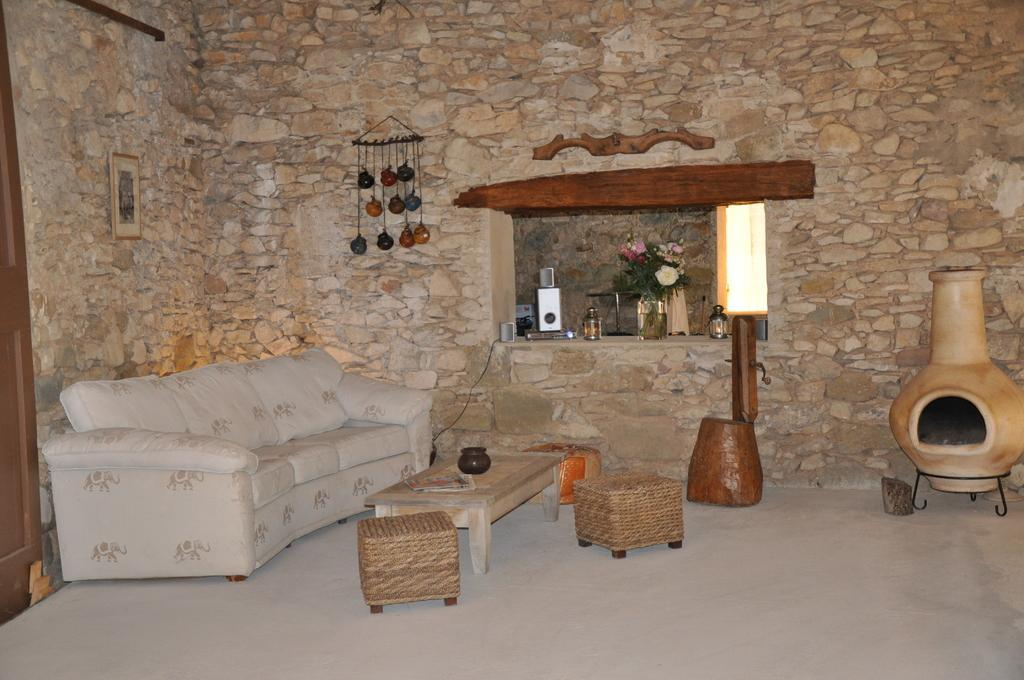What type of furniture is present in the image? There is a couch, a table, and two chairs in the image. What can be seen in the background of the image? There is a wall, a flower pot, and another table in the background of the image. Can you see a squirrel climbing the wall in the image? There is no squirrel present in the image. What type of wish can be granted by the flower pot in the image? The image does not depict a magical flower pot that can grant wishes. 